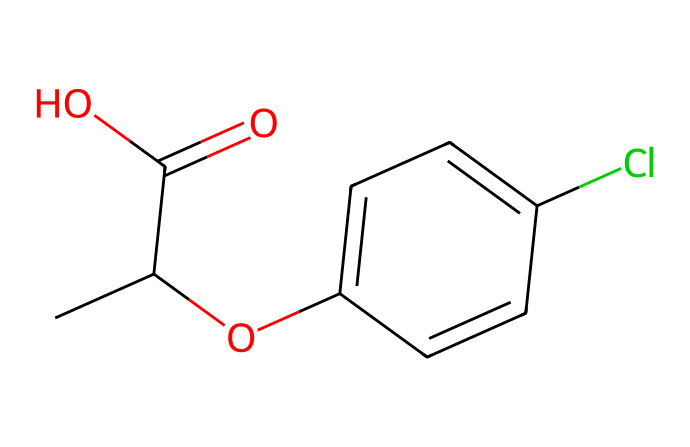What is the total number of carbon atoms in mecoprop? Counting the carbon atoms in the SMILES representation, we see two in the isopropyl group (CC), one in the carbonyl (C(=O)), and four in the aromatic ring (c1ccc). This totals to seven carbon atoms.
Answer: seven How many chlorine atoms are present in the structure? Looking at the SMILES, there is a single "Cl" notation indicating the presence of one chlorine atom attached to the aromatic ring.
Answer: one What functional groups are present in mecoprop? The SMILES reveals a carboxylic acid group (C(=O)O) and an ether group (O) linked to the aromatic system, indicating both functional groups are present.
Answer: carboxylic acid and ether Which part of the structure represents the herbicidal activity? The presence of the carboxylic acid group (C(=O)O) suggests interaction with plant growth regulation mechanisms, often associated with herbicidal activity.
Answer: carboxylic acid group What is the molecular formula of mecoprop? To derive the molecular formula, we count the atoms: seven carbons, seven hydrogens (C7H7), one chlorine (Cl), and two oxygens (O2). Putting this together, the molecular formula is C7H7ClO2.
Answer: C7H7ClO2 Is mecoprop more likely to be persistent in the environment due to its structure? The presence of multiple stable functional groups and lack of easily hydrolyzable bonds suggests it could be stable in soil and water, leading to environmental persistence.
Answer: yes 